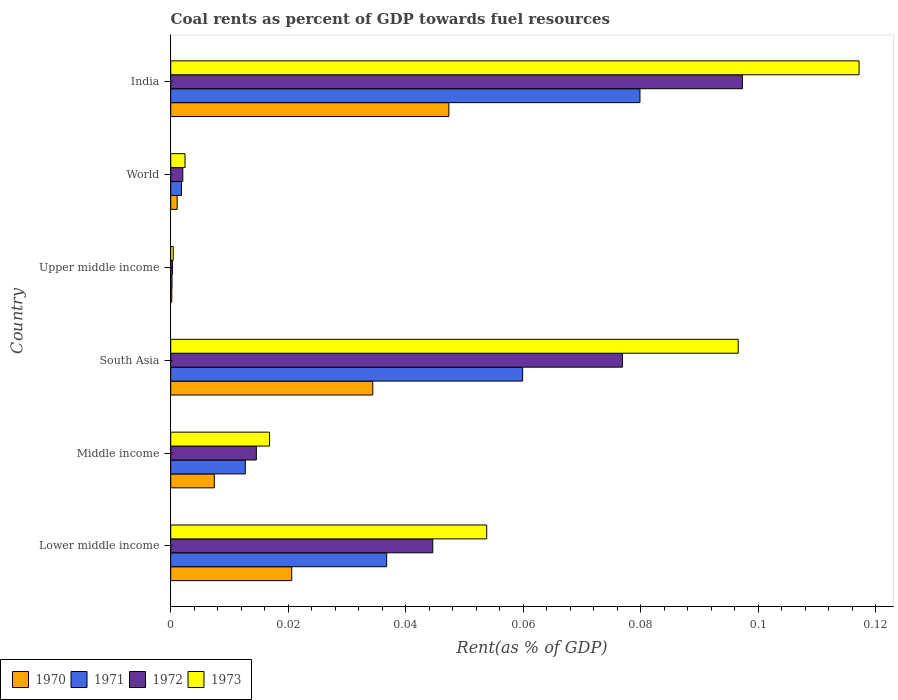How many groups of bars are there?
Your answer should be compact. 6. Are the number of bars on each tick of the Y-axis equal?
Provide a succinct answer. Yes. How many bars are there on the 5th tick from the top?
Offer a very short reply. 4. How many bars are there on the 6th tick from the bottom?
Give a very brief answer. 4. In how many cases, is the number of bars for a given country not equal to the number of legend labels?
Your answer should be very brief. 0. What is the coal rent in 1972 in India?
Your answer should be compact. 0.1. Across all countries, what is the maximum coal rent in 1971?
Your answer should be very brief. 0.08. Across all countries, what is the minimum coal rent in 1971?
Give a very brief answer. 0. In which country was the coal rent in 1973 minimum?
Provide a short and direct response. Upper middle income. What is the total coal rent in 1972 in the graph?
Your answer should be very brief. 0.24. What is the difference between the coal rent in 1970 in Middle income and that in Upper middle income?
Keep it short and to the point. 0.01. What is the difference between the coal rent in 1970 in Lower middle income and the coal rent in 1973 in Middle income?
Offer a very short reply. 0. What is the average coal rent in 1970 per country?
Ensure brevity in your answer.  0.02. What is the difference between the coal rent in 1971 and coal rent in 1970 in Lower middle income?
Provide a succinct answer. 0.02. What is the ratio of the coal rent in 1972 in India to that in Lower middle income?
Provide a short and direct response. 2.18. What is the difference between the highest and the second highest coal rent in 1972?
Make the answer very short. 0.02. What is the difference between the highest and the lowest coal rent in 1972?
Make the answer very short. 0.1. Are the values on the major ticks of X-axis written in scientific E-notation?
Offer a very short reply. No. Does the graph contain any zero values?
Offer a terse response. No. How are the legend labels stacked?
Your response must be concise. Horizontal. What is the title of the graph?
Ensure brevity in your answer.  Coal rents as percent of GDP towards fuel resources. Does "1979" appear as one of the legend labels in the graph?
Your answer should be very brief. No. What is the label or title of the X-axis?
Your answer should be very brief. Rent(as % of GDP). What is the label or title of the Y-axis?
Provide a succinct answer. Country. What is the Rent(as % of GDP) in 1970 in Lower middle income?
Make the answer very short. 0.02. What is the Rent(as % of GDP) in 1971 in Lower middle income?
Keep it short and to the point. 0.04. What is the Rent(as % of GDP) in 1972 in Lower middle income?
Make the answer very short. 0.04. What is the Rent(as % of GDP) in 1973 in Lower middle income?
Your response must be concise. 0.05. What is the Rent(as % of GDP) in 1970 in Middle income?
Provide a succinct answer. 0.01. What is the Rent(as % of GDP) of 1971 in Middle income?
Provide a succinct answer. 0.01. What is the Rent(as % of GDP) in 1972 in Middle income?
Offer a terse response. 0.01. What is the Rent(as % of GDP) in 1973 in Middle income?
Your answer should be very brief. 0.02. What is the Rent(as % of GDP) of 1970 in South Asia?
Offer a terse response. 0.03. What is the Rent(as % of GDP) of 1971 in South Asia?
Your answer should be very brief. 0.06. What is the Rent(as % of GDP) in 1972 in South Asia?
Provide a succinct answer. 0.08. What is the Rent(as % of GDP) of 1973 in South Asia?
Keep it short and to the point. 0.1. What is the Rent(as % of GDP) in 1970 in Upper middle income?
Keep it short and to the point. 0. What is the Rent(as % of GDP) of 1971 in Upper middle income?
Give a very brief answer. 0. What is the Rent(as % of GDP) in 1972 in Upper middle income?
Give a very brief answer. 0. What is the Rent(as % of GDP) of 1973 in Upper middle income?
Your response must be concise. 0. What is the Rent(as % of GDP) in 1970 in World?
Offer a terse response. 0. What is the Rent(as % of GDP) in 1971 in World?
Your answer should be compact. 0. What is the Rent(as % of GDP) of 1972 in World?
Keep it short and to the point. 0. What is the Rent(as % of GDP) of 1973 in World?
Make the answer very short. 0. What is the Rent(as % of GDP) in 1970 in India?
Ensure brevity in your answer.  0.05. What is the Rent(as % of GDP) in 1971 in India?
Your answer should be compact. 0.08. What is the Rent(as % of GDP) in 1972 in India?
Offer a very short reply. 0.1. What is the Rent(as % of GDP) in 1973 in India?
Give a very brief answer. 0.12. Across all countries, what is the maximum Rent(as % of GDP) in 1970?
Offer a very short reply. 0.05. Across all countries, what is the maximum Rent(as % of GDP) in 1971?
Give a very brief answer. 0.08. Across all countries, what is the maximum Rent(as % of GDP) in 1972?
Provide a short and direct response. 0.1. Across all countries, what is the maximum Rent(as % of GDP) in 1973?
Keep it short and to the point. 0.12. Across all countries, what is the minimum Rent(as % of GDP) in 1970?
Make the answer very short. 0. Across all countries, what is the minimum Rent(as % of GDP) in 1971?
Ensure brevity in your answer.  0. Across all countries, what is the minimum Rent(as % of GDP) of 1972?
Keep it short and to the point. 0. Across all countries, what is the minimum Rent(as % of GDP) of 1973?
Your answer should be very brief. 0. What is the total Rent(as % of GDP) of 1970 in the graph?
Make the answer very short. 0.11. What is the total Rent(as % of GDP) of 1971 in the graph?
Offer a very short reply. 0.19. What is the total Rent(as % of GDP) in 1972 in the graph?
Offer a terse response. 0.24. What is the total Rent(as % of GDP) of 1973 in the graph?
Offer a very short reply. 0.29. What is the difference between the Rent(as % of GDP) of 1970 in Lower middle income and that in Middle income?
Your answer should be compact. 0.01. What is the difference between the Rent(as % of GDP) of 1971 in Lower middle income and that in Middle income?
Keep it short and to the point. 0.02. What is the difference between the Rent(as % of GDP) in 1972 in Lower middle income and that in Middle income?
Ensure brevity in your answer.  0.03. What is the difference between the Rent(as % of GDP) in 1973 in Lower middle income and that in Middle income?
Your answer should be compact. 0.04. What is the difference between the Rent(as % of GDP) of 1970 in Lower middle income and that in South Asia?
Provide a short and direct response. -0.01. What is the difference between the Rent(as % of GDP) in 1971 in Lower middle income and that in South Asia?
Offer a very short reply. -0.02. What is the difference between the Rent(as % of GDP) of 1972 in Lower middle income and that in South Asia?
Your answer should be compact. -0.03. What is the difference between the Rent(as % of GDP) in 1973 in Lower middle income and that in South Asia?
Your answer should be very brief. -0.04. What is the difference between the Rent(as % of GDP) in 1970 in Lower middle income and that in Upper middle income?
Provide a short and direct response. 0.02. What is the difference between the Rent(as % of GDP) of 1971 in Lower middle income and that in Upper middle income?
Offer a terse response. 0.04. What is the difference between the Rent(as % of GDP) in 1972 in Lower middle income and that in Upper middle income?
Your response must be concise. 0.04. What is the difference between the Rent(as % of GDP) in 1973 in Lower middle income and that in Upper middle income?
Offer a very short reply. 0.05. What is the difference between the Rent(as % of GDP) in 1970 in Lower middle income and that in World?
Your answer should be very brief. 0.02. What is the difference between the Rent(as % of GDP) of 1971 in Lower middle income and that in World?
Offer a terse response. 0.03. What is the difference between the Rent(as % of GDP) of 1972 in Lower middle income and that in World?
Keep it short and to the point. 0.04. What is the difference between the Rent(as % of GDP) in 1973 in Lower middle income and that in World?
Ensure brevity in your answer.  0.05. What is the difference between the Rent(as % of GDP) of 1970 in Lower middle income and that in India?
Provide a succinct answer. -0.03. What is the difference between the Rent(as % of GDP) in 1971 in Lower middle income and that in India?
Keep it short and to the point. -0.04. What is the difference between the Rent(as % of GDP) in 1972 in Lower middle income and that in India?
Keep it short and to the point. -0.05. What is the difference between the Rent(as % of GDP) in 1973 in Lower middle income and that in India?
Offer a very short reply. -0.06. What is the difference between the Rent(as % of GDP) in 1970 in Middle income and that in South Asia?
Your answer should be very brief. -0.03. What is the difference between the Rent(as % of GDP) of 1971 in Middle income and that in South Asia?
Give a very brief answer. -0.05. What is the difference between the Rent(as % of GDP) in 1972 in Middle income and that in South Asia?
Your answer should be very brief. -0.06. What is the difference between the Rent(as % of GDP) of 1973 in Middle income and that in South Asia?
Give a very brief answer. -0.08. What is the difference between the Rent(as % of GDP) in 1970 in Middle income and that in Upper middle income?
Make the answer very short. 0.01. What is the difference between the Rent(as % of GDP) of 1971 in Middle income and that in Upper middle income?
Keep it short and to the point. 0.01. What is the difference between the Rent(as % of GDP) of 1972 in Middle income and that in Upper middle income?
Provide a succinct answer. 0.01. What is the difference between the Rent(as % of GDP) of 1973 in Middle income and that in Upper middle income?
Provide a succinct answer. 0.02. What is the difference between the Rent(as % of GDP) of 1970 in Middle income and that in World?
Your answer should be very brief. 0.01. What is the difference between the Rent(as % of GDP) of 1971 in Middle income and that in World?
Your answer should be very brief. 0.01. What is the difference between the Rent(as % of GDP) of 1972 in Middle income and that in World?
Make the answer very short. 0.01. What is the difference between the Rent(as % of GDP) in 1973 in Middle income and that in World?
Ensure brevity in your answer.  0.01. What is the difference between the Rent(as % of GDP) of 1970 in Middle income and that in India?
Your answer should be compact. -0.04. What is the difference between the Rent(as % of GDP) in 1971 in Middle income and that in India?
Offer a terse response. -0.07. What is the difference between the Rent(as % of GDP) in 1972 in Middle income and that in India?
Give a very brief answer. -0.08. What is the difference between the Rent(as % of GDP) in 1973 in Middle income and that in India?
Your answer should be very brief. -0.1. What is the difference between the Rent(as % of GDP) of 1970 in South Asia and that in Upper middle income?
Your answer should be compact. 0.03. What is the difference between the Rent(as % of GDP) of 1971 in South Asia and that in Upper middle income?
Your answer should be very brief. 0.06. What is the difference between the Rent(as % of GDP) in 1972 in South Asia and that in Upper middle income?
Offer a very short reply. 0.08. What is the difference between the Rent(as % of GDP) of 1973 in South Asia and that in Upper middle income?
Offer a very short reply. 0.1. What is the difference between the Rent(as % of GDP) in 1970 in South Asia and that in World?
Your response must be concise. 0.03. What is the difference between the Rent(as % of GDP) of 1971 in South Asia and that in World?
Your answer should be very brief. 0.06. What is the difference between the Rent(as % of GDP) in 1972 in South Asia and that in World?
Offer a terse response. 0.07. What is the difference between the Rent(as % of GDP) of 1973 in South Asia and that in World?
Offer a very short reply. 0.09. What is the difference between the Rent(as % of GDP) in 1970 in South Asia and that in India?
Your response must be concise. -0.01. What is the difference between the Rent(as % of GDP) in 1971 in South Asia and that in India?
Give a very brief answer. -0.02. What is the difference between the Rent(as % of GDP) in 1972 in South Asia and that in India?
Your response must be concise. -0.02. What is the difference between the Rent(as % of GDP) of 1973 in South Asia and that in India?
Provide a short and direct response. -0.02. What is the difference between the Rent(as % of GDP) in 1970 in Upper middle income and that in World?
Provide a short and direct response. -0. What is the difference between the Rent(as % of GDP) in 1971 in Upper middle income and that in World?
Provide a succinct answer. -0. What is the difference between the Rent(as % of GDP) in 1972 in Upper middle income and that in World?
Keep it short and to the point. -0. What is the difference between the Rent(as % of GDP) in 1973 in Upper middle income and that in World?
Your answer should be compact. -0. What is the difference between the Rent(as % of GDP) of 1970 in Upper middle income and that in India?
Your response must be concise. -0.05. What is the difference between the Rent(as % of GDP) of 1971 in Upper middle income and that in India?
Give a very brief answer. -0.08. What is the difference between the Rent(as % of GDP) in 1972 in Upper middle income and that in India?
Your answer should be compact. -0.1. What is the difference between the Rent(as % of GDP) in 1973 in Upper middle income and that in India?
Your answer should be very brief. -0.12. What is the difference between the Rent(as % of GDP) of 1970 in World and that in India?
Keep it short and to the point. -0.05. What is the difference between the Rent(as % of GDP) of 1971 in World and that in India?
Offer a terse response. -0.08. What is the difference between the Rent(as % of GDP) of 1972 in World and that in India?
Offer a very short reply. -0.1. What is the difference between the Rent(as % of GDP) in 1973 in World and that in India?
Offer a terse response. -0.11. What is the difference between the Rent(as % of GDP) of 1970 in Lower middle income and the Rent(as % of GDP) of 1971 in Middle income?
Your answer should be very brief. 0.01. What is the difference between the Rent(as % of GDP) in 1970 in Lower middle income and the Rent(as % of GDP) in 1972 in Middle income?
Your response must be concise. 0.01. What is the difference between the Rent(as % of GDP) in 1970 in Lower middle income and the Rent(as % of GDP) in 1973 in Middle income?
Your response must be concise. 0. What is the difference between the Rent(as % of GDP) of 1971 in Lower middle income and the Rent(as % of GDP) of 1972 in Middle income?
Make the answer very short. 0.02. What is the difference between the Rent(as % of GDP) in 1971 in Lower middle income and the Rent(as % of GDP) in 1973 in Middle income?
Make the answer very short. 0.02. What is the difference between the Rent(as % of GDP) of 1972 in Lower middle income and the Rent(as % of GDP) of 1973 in Middle income?
Make the answer very short. 0.03. What is the difference between the Rent(as % of GDP) in 1970 in Lower middle income and the Rent(as % of GDP) in 1971 in South Asia?
Offer a very short reply. -0.04. What is the difference between the Rent(as % of GDP) in 1970 in Lower middle income and the Rent(as % of GDP) in 1972 in South Asia?
Offer a very short reply. -0.06. What is the difference between the Rent(as % of GDP) of 1970 in Lower middle income and the Rent(as % of GDP) of 1973 in South Asia?
Your answer should be very brief. -0.08. What is the difference between the Rent(as % of GDP) of 1971 in Lower middle income and the Rent(as % of GDP) of 1972 in South Asia?
Your answer should be compact. -0.04. What is the difference between the Rent(as % of GDP) in 1971 in Lower middle income and the Rent(as % of GDP) in 1973 in South Asia?
Give a very brief answer. -0.06. What is the difference between the Rent(as % of GDP) in 1972 in Lower middle income and the Rent(as % of GDP) in 1973 in South Asia?
Make the answer very short. -0.05. What is the difference between the Rent(as % of GDP) of 1970 in Lower middle income and the Rent(as % of GDP) of 1971 in Upper middle income?
Offer a very short reply. 0.02. What is the difference between the Rent(as % of GDP) in 1970 in Lower middle income and the Rent(as % of GDP) in 1972 in Upper middle income?
Your answer should be very brief. 0.02. What is the difference between the Rent(as % of GDP) of 1970 in Lower middle income and the Rent(as % of GDP) of 1973 in Upper middle income?
Give a very brief answer. 0.02. What is the difference between the Rent(as % of GDP) in 1971 in Lower middle income and the Rent(as % of GDP) in 1972 in Upper middle income?
Provide a short and direct response. 0.04. What is the difference between the Rent(as % of GDP) of 1971 in Lower middle income and the Rent(as % of GDP) of 1973 in Upper middle income?
Give a very brief answer. 0.04. What is the difference between the Rent(as % of GDP) in 1972 in Lower middle income and the Rent(as % of GDP) in 1973 in Upper middle income?
Provide a short and direct response. 0.04. What is the difference between the Rent(as % of GDP) in 1970 in Lower middle income and the Rent(as % of GDP) in 1971 in World?
Keep it short and to the point. 0.02. What is the difference between the Rent(as % of GDP) in 1970 in Lower middle income and the Rent(as % of GDP) in 1972 in World?
Offer a terse response. 0.02. What is the difference between the Rent(as % of GDP) in 1970 in Lower middle income and the Rent(as % of GDP) in 1973 in World?
Your response must be concise. 0.02. What is the difference between the Rent(as % of GDP) of 1971 in Lower middle income and the Rent(as % of GDP) of 1972 in World?
Keep it short and to the point. 0.03. What is the difference between the Rent(as % of GDP) in 1971 in Lower middle income and the Rent(as % of GDP) in 1973 in World?
Provide a short and direct response. 0.03. What is the difference between the Rent(as % of GDP) in 1972 in Lower middle income and the Rent(as % of GDP) in 1973 in World?
Make the answer very short. 0.04. What is the difference between the Rent(as % of GDP) of 1970 in Lower middle income and the Rent(as % of GDP) of 1971 in India?
Provide a succinct answer. -0.06. What is the difference between the Rent(as % of GDP) of 1970 in Lower middle income and the Rent(as % of GDP) of 1972 in India?
Offer a terse response. -0.08. What is the difference between the Rent(as % of GDP) of 1970 in Lower middle income and the Rent(as % of GDP) of 1973 in India?
Ensure brevity in your answer.  -0.1. What is the difference between the Rent(as % of GDP) in 1971 in Lower middle income and the Rent(as % of GDP) in 1972 in India?
Provide a short and direct response. -0.06. What is the difference between the Rent(as % of GDP) in 1971 in Lower middle income and the Rent(as % of GDP) in 1973 in India?
Offer a terse response. -0.08. What is the difference between the Rent(as % of GDP) of 1972 in Lower middle income and the Rent(as % of GDP) of 1973 in India?
Offer a very short reply. -0.07. What is the difference between the Rent(as % of GDP) of 1970 in Middle income and the Rent(as % of GDP) of 1971 in South Asia?
Give a very brief answer. -0.05. What is the difference between the Rent(as % of GDP) of 1970 in Middle income and the Rent(as % of GDP) of 1972 in South Asia?
Your answer should be very brief. -0.07. What is the difference between the Rent(as % of GDP) of 1970 in Middle income and the Rent(as % of GDP) of 1973 in South Asia?
Provide a short and direct response. -0.09. What is the difference between the Rent(as % of GDP) in 1971 in Middle income and the Rent(as % of GDP) in 1972 in South Asia?
Offer a very short reply. -0.06. What is the difference between the Rent(as % of GDP) of 1971 in Middle income and the Rent(as % of GDP) of 1973 in South Asia?
Your response must be concise. -0.08. What is the difference between the Rent(as % of GDP) of 1972 in Middle income and the Rent(as % of GDP) of 1973 in South Asia?
Give a very brief answer. -0.08. What is the difference between the Rent(as % of GDP) of 1970 in Middle income and the Rent(as % of GDP) of 1971 in Upper middle income?
Offer a very short reply. 0.01. What is the difference between the Rent(as % of GDP) of 1970 in Middle income and the Rent(as % of GDP) of 1972 in Upper middle income?
Offer a terse response. 0.01. What is the difference between the Rent(as % of GDP) of 1970 in Middle income and the Rent(as % of GDP) of 1973 in Upper middle income?
Ensure brevity in your answer.  0.01. What is the difference between the Rent(as % of GDP) of 1971 in Middle income and the Rent(as % of GDP) of 1972 in Upper middle income?
Your response must be concise. 0.01. What is the difference between the Rent(as % of GDP) of 1971 in Middle income and the Rent(as % of GDP) of 1973 in Upper middle income?
Offer a terse response. 0.01. What is the difference between the Rent(as % of GDP) of 1972 in Middle income and the Rent(as % of GDP) of 1973 in Upper middle income?
Your answer should be very brief. 0.01. What is the difference between the Rent(as % of GDP) of 1970 in Middle income and the Rent(as % of GDP) of 1971 in World?
Provide a short and direct response. 0.01. What is the difference between the Rent(as % of GDP) of 1970 in Middle income and the Rent(as % of GDP) of 1972 in World?
Ensure brevity in your answer.  0.01. What is the difference between the Rent(as % of GDP) in 1970 in Middle income and the Rent(as % of GDP) in 1973 in World?
Provide a short and direct response. 0.01. What is the difference between the Rent(as % of GDP) of 1971 in Middle income and the Rent(as % of GDP) of 1972 in World?
Ensure brevity in your answer.  0.01. What is the difference between the Rent(as % of GDP) of 1971 in Middle income and the Rent(as % of GDP) of 1973 in World?
Your answer should be very brief. 0.01. What is the difference between the Rent(as % of GDP) of 1972 in Middle income and the Rent(as % of GDP) of 1973 in World?
Keep it short and to the point. 0.01. What is the difference between the Rent(as % of GDP) of 1970 in Middle income and the Rent(as % of GDP) of 1971 in India?
Ensure brevity in your answer.  -0.07. What is the difference between the Rent(as % of GDP) in 1970 in Middle income and the Rent(as % of GDP) in 1972 in India?
Your answer should be compact. -0.09. What is the difference between the Rent(as % of GDP) in 1970 in Middle income and the Rent(as % of GDP) in 1973 in India?
Offer a terse response. -0.11. What is the difference between the Rent(as % of GDP) in 1971 in Middle income and the Rent(as % of GDP) in 1972 in India?
Keep it short and to the point. -0.08. What is the difference between the Rent(as % of GDP) in 1971 in Middle income and the Rent(as % of GDP) in 1973 in India?
Your answer should be compact. -0.1. What is the difference between the Rent(as % of GDP) of 1972 in Middle income and the Rent(as % of GDP) of 1973 in India?
Your response must be concise. -0.1. What is the difference between the Rent(as % of GDP) of 1970 in South Asia and the Rent(as % of GDP) of 1971 in Upper middle income?
Your answer should be compact. 0.03. What is the difference between the Rent(as % of GDP) of 1970 in South Asia and the Rent(as % of GDP) of 1972 in Upper middle income?
Provide a succinct answer. 0.03. What is the difference between the Rent(as % of GDP) of 1970 in South Asia and the Rent(as % of GDP) of 1973 in Upper middle income?
Provide a short and direct response. 0.03. What is the difference between the Rent(as % of GDP) of 1971 in South Asia and the Rent(as % of GDP) of 1972 in Upper middle income?
Make the answer very short. 0.06. What is the difference between the Rent(as % of GDP) in 1971 in South Asia and the Rent(as % of GDP) in 1973 in Upper middle income?
Offer a terse response. 0.06. What is the difference between the Rent(as % of GDP) of 1972 in South Asia and the Rent(as % of GDP) of 1973 in Upper middle income?
Keep it short and to the point. 0.08. What is the difference between the Rent(as % of GDP) in 1970 in South Asia and the Rent(as % of GDP) in 1971 in World?
Provide a succinct answer. 0.03. What is the difference between the Rent(as % of GDP) of 1970 in South Asia and the Rent(as % of GDP) of 1972 in World?
Your answer should be very brief. 0.03. What is the difference between the Rent(as % of GDP) in 1970 in South Asia and the Rent(as % of GDP) in 1973 in World?
Give a very brief answer. 0.03. What is the difference between the Rent(as % of GDP) in 1971 in South Asia and the Rent(as % of GDP) in 1972 in World?
Provide a succinct answer. 0.06. What is the difference between the Rent(as % of GDP) in 1971 in South Asia and the Rent(as % of GDP) in 1973 in World?
Your answer should be very brief. 0.06. What is the difference between the Rent(as % of GDP) of 1972 in South Asia and the Rent(as % of GDP) of 1973 in World?
Provide a short and direct response. 0.07. What is the difference between the Rent(as % of GDP) of 1970 in South Asia and the Rent(as % of GDP) of 1971 in India?
Your answer should be compact. -0.05. What is the difference between the Rent(as % of GDP) in 1970 in South Asia and the Rent(as % of GDP) in 1972 in India?
Give a very brief answer. -0.06. What is the difference between the Rent(as % of GDP) in 1970 in South Asia and the Rent(as % of GDP) in 1973 in India?
Provide a succinct answer. -0.08. What is the difference between the Rent(as % of GDP) of 1971 in South Asia and the Rent(as % of GDP) of 1972 in India?
Keep it short and to the point. -0.04. What is the difference between the Rent(as % of GDP) in 1971 in South Asia and the Rent(as % of GDP) in 1973 in India?
Provide a short and direct response. -0.06. What is the difference between the Rent(as % of GDP) in 1972 in South Asia and the Rent(as % of GDP) in 1973 in India?
Offer a terse response. -0.04. What is the difference between the Rent(as % of GDP) of 1970 in Upper middle income and the Rent(as % of GDP) of 1971 in World?
Keep it short and to the point. -0. What is the difference between the Rent(as % of GDP) in 1970 in Upper middle income and the Rent(as % of GDP) in 1972 in World?
Offer a very short reply. -0. What is the difference between the Rent(as % of GDP) of 1970 in Upper middle income and the Rent(as % of GDP) of 1973 in World?
Your response must be concise. -0. What is the difference between the Rent(as % of GDP) in 1971 in Upper middle income and the Rent(as % of GDP) in 1972 in World?
Keep it short and to the point. -0. What is the difference between the Rent(as % of GDP) of 1971 in Upper middle income and the Rent(as % of GDP) of 1973 in World?
Your answer should be compact. -0. What is the difference between the Rent(as % of GDP) of 1972 in Upper middle income and the Rent(as % of GDP) of 1973 in World?
Make the answer very short. -0. What is the difference between the Rent(as % of GDP) in 1970 in Upper middle income and the Rent(as % of GDP) in 1971 in India?
Your response must be concise. -0.08. What is the difference between the Rent(as % of GDP) of 1970 in Upper middle income and the Rent(as % of GDP) of 1972 in India?
Ensure brevity in your answer.  -0.1. What is the difference between the Rent(as % of GDP) in 1970 in Upper middle income and the Rent(as % of GDP) in 1973 in India?
Your answer should be compact. -0.12. What is the difference between the Rent(as % of GDP) in 1971 in Upper middle income and the Rent(as % of GDP) in 1972 in India?
Your answer should be compact. -0.1. What is the difference between the Rent(as % of GDP) of 1971 in Upper middle income and the Rent(as % of GDP) of 1973 in India?
Ensure brevity in your answer.  -0.12. What is the difference between the Rent(as % of GDP) of 1972 in Upper middle income and the Rent(as % of GDP) of 1973 in India?
Offer a terse response. -0.12. What is the difference between the Rent(as % of GDP) in 1970 in World and the Rent(as % of GDP) in 1971 in India?
Offer a terse response. -0.08. What is the difference between the Rent(as % of GDP) in 1970 in World and the Rent(as % of GDP) in 1972 in India?
Provide a succinct answer. -0.1. What is the difference between the Rent(as % of GDP) in 1970 in World and the Rent(as % of GDP) in 1973 in India?
Ensure brevity in your answer.  -0.12. What is the difference between the Rent(as % of GDP) in 1971 in World and the Rent(as % of GDP) in 1972 in India?
Your response must be concise. -0.1. What is the difference between the Rent(as % of GDP) of 1971 in World and the Rent(as % of GDP) of 1973 in India?
Provide a short and direct response. -0.12. What is the difference between the Rent(as % of GDP) in 1972 in World and the Rent(as % of GDP) in 1973 in India?
Keep it short and to the point. -0.12. What is the average Rent(as % of GDP) in 1970 per country?
Provide a short and direct response. 0.02. What is the average Rent(as % of GDP) in 1971 per country?
Give a very brief answer. 0.03. What is the average Rent(as % of GDP) of 1972 per country?
Your response must be concise. 0.04. What is the average Rent(as % of GDP) of 1973 per country?
Keep it short and to the point. 0.05. What is the difference between the Rent(as % of GDP) of 1970 and Rent(as % of GDP) of 1971 in Lower middle income?
Give a very brief answer. -0.02. What is the difference between the Rent(as % of GDP) in 1970 and Rent(as % of GDP) in 1972 in Lower middle income?
Your answer should be very brief. -0.02. What is the difference between the Rent(as % of GDP) in 1970 and Rent(as % of GDP) in 1973 in Lower middle income?
Your answer should be very brief. -0.03. What is the difference between the Rent(as % of GDP) in 1971 and Rent(as % of GDP) in 1972 in Lower middle income?
Give a very brief answer. -0.01. What is the difference between the Rent(as % of GDP) of 1971 and Rent(as % of GDP) of 1973 in Lower middle income?
Give a very brief answer. -0.02. What is the difference between the Rent(as % of GDP) in 1972 and Rent(as % of GDP) in 1973 in Lower middle income?
Give a very brief answer. -0.01. What is the difference between the Rent(as % of GDP) in 1970 and Rent(as % of GDP) in 1971 in Middle income?
Offer a very short reply. -0.01. What is the difference between the Rent(as % of GDP) in 1970 and Rent(as % of GDP) in 1972 in Middle income?
Make the answer very short. -0.01. What is the difference between the Rent(as % of GDP) of 1970 and Rent(as % of GDP) of 1973 in Middle income?
Give a very brief answer. -0.01. What is the difference between the Rent(as % of GDP) of 1971 and Rent(as % of GDP) of 1972 in Middle income?
Give a very brief answer. -0. What is the difference between the Rent(as % of GDP) of 1971 and Rent(as % of GDP) of 1973 in Middle income?
Your response must be concise. -0. What is the difference between the Rent(as % of GDP) of 1972 and Rent(as % of GDP) of 1973 in Middle income?
Keep it short and to the point. -0. What is the difference between the Rent(as % of GDP) of 1970 and Rent(as % of GDP) of 1971 in South Asia?
Make the answer very short. -0.03. What is the difference between the Rent(as % of GDP) of 1970 and Rent(as % of GDP) of 1972 in South Asia?
Provide a succinct answer. -0.04. What is the difference between the Rent(as % of GDP) of 1970 and Rent(as % of GDP) of 1973 in South Asia?
Offer a terse response. -0.06. What is the difference between the Rent(as % of GDP) in 1971 and Rent(as % of GDP) in 1972 in South Asia?
Provide a succinct answer. -0.02. What is the difference between the Rent(as % of GDP) in 1971 and Rent(as % of GDP) in 1973 in South Asia?
Your response must be concise. -0.04. What is the difference between the Rent(as % of GDP) of 1972 and Rent(as % of GDP) of 1973 in South Asia?
Offer a terse response. -0.02. What is the difference between the Rent(as % of GDP) of 1970 and Rent(as % of GDP) of 1972 in Upper middle income?
Offer a very short reply. -0. What is the difference between the Rent(as % of GDP) in 1970 and Rent(as % of GDP) in 1973 in Upper middle income?
Ensure brevity in your answer.  -0. What is the difference between the Rent(as % of GDP) of 1971 and Rent(as % of GDP) of 1972 in Upper middle income?
Provide a succinct answer. -0. What is the difference between the Rent(as % of GDP) of 1971 and Rent(as % of GDP) of 1973 in Upper middle income?
Your answer should be very brief. -0. What is the difference between the Rent(as % of GDP) of 1972 and Rent(as % of GDP) of 1973 in Upper middle income?
Keep it short and to the point. -0. What is the difference between the Rent(as % of GDP) of 1970 and Rent(as % of GDP) of 1971 in World?
Offer a terse response. -0. What is the difference between the Rent(as % of GDP) of 1970 and Rent(as % of GDP) of 1972 in World?
Your response must be concise. -0. What is the difference between the Rent(as % of GDP) of 1970 and Rent(as % of GDP) of 1973 in World?
Provide a succinct answer. -0. What is the difference between the Rent(as % of GDP) in 1971 and Rent(as % of GDP) in 1972 in World?
Give a very brief answer. -0. What is the difference between the Rent(as % of GDP) of 1971 and Rent(as % of GDP) of 1973 in World?
Offer a very short reply. -0. What is the difference between the Rent(as % of GDP) in 1972 and Rent(as % of GDP) in 1973 in World?
Provide a short and direct response. -0. What is the difference between the Rent(as % of GDP) in 1970 and Rent(as % of GDP) in 1971 in India?
Ensure brevity in your answer.  -0.03. What is the difference between the Rent(as % of GDP) in 1970 and Rent(as % of GDP) in 1973 in India?
Your response must be concise. -0.07. What is the difference between the Rent(as % of GDP) of 1971 and Rent(as % of GDP) of 1972 in India?
Offer a very short reply. -0.02. What is the difference between the Rent(as % of GDP) in 1971 and Rent(as % of GDP) in 1973 in India?
Your response must be concise. -0.04. What is the difference between the Rent(as % of GDP) of 1972 and Rent(as % of GDP) of 1973 in India?
Provide a short and direct response. -0.02. What is the ratio of the Rent(as % of GDP) of 1970 in Lower middle income to that in Middle income?
Your response must be concise. 2.78. What is the ratio of the Rent(as % of GDP) in 1971 in Lower middle income to that in Middle income?
Your answer should be compact. 2.9. What is the ratio of the Rent(as % of GDP) of 1972 in Lower middle income to that in Middle income?
Offer a terse response. 3.06. What is the ratio of the Rent(as % of GDP) of 1973 in Lower middle income to that in Middle income?
Your answer should be compact. 3.2. What is the ratio of the Rent(as % of GDP) of 1970 in Lower middle income to that in South Asia?
Your response must be concise. 0.6. What is the ratio of the Rent(as % of GDP) in 1971 in Lower middle income to that in South Asia?
Your answer should be compact. 0.61. What is the ratio of the Rent(as % of GDP) of 1972 in Lower middle income to that in South Asia?
Make the answer very short. 0.58. What is the ratio of the Rent(as % of GDP) of 1973 in Lower middle income to that in South Asia?
Offer a terse response. 0.56. What is the ratio of the Rent(as % of GDP) of 1970 in Lower middle income to that in Upper middle income?
Your answer should be very brief. 112.03. What is the ratio of the Rent(as % of GDP) in 1971 in Lower middle income to that in Upper middle income?
Make the answer very short. 167.98. What is the ratio of the Rent(as % of GDP) in 1972 in Lower middle income to that in Upper middle income?
Make the answer very short. 156.82. What is the ratio of the Rent(as % of GDP) of 1973 in Lower middle income to that in Upper middle income?
Your answer should be very brief. 124.82. What is the ratio of the Rent(as % of GDP) of 1970 in Lower middle income to that in World?
Your answer should be very brief. 18.71. What is the ratio of the Rent(as % of GDP) of 1971 in Lower middle income to that in World?
Ensure brevity in your answer.  20.06. What is the ratio of the Rent(as % of GDP) in 1972 in Lower middle income to that in World?
Ensure brevity in your answer.  21.7. What is the ratio of the Rent(as % of GDP) in 1973 in Lower middle income to that in World?
Ensure brevity in your answer.  22.07. What is the ratio of the Rent(as % of GDP) of 1970 in Lower middle income to that in India?
Your response must be concise. 0.44. What is the ratio of the Rent(as % of GDP) of 1971 in Lower middle income to that in India?
Offer a terse response. 0.46. What is the ratio of the Rent(as % of GDP) of 1972 in Lower middle income to that in India?
Provide a succinct answer. 0.46. What is the ratio of the Rent(as % of GDP) of 1973 in Lower middle income to that in India?
Your answer should be compact. 0.46. What is the ratio of the Rent(as % of GDP) in 1970 in Middle income to that in South Asia?
Provide a short and direct response. 0.22. What is the ratio of the Rent(as % of GDP) in 1971 in Middle income to that in South Asia?
Give a very brief answer. 0.21. What is the ratio of the Rent(as % of GDP) of 1972 in Middle income to that in South Asia?
Keep it short and to the point. 0.19. What is the ratio of the Rent(as % of GDP) of 1973 in Middle income to that in South Asia?
Your answer should be very brief. 0.17. What is the ratio of the Rent(as % of GDP) of 1970 in Middle income to that in Upper middle income?
Offer a terse response. 40.36. What is the ratio of the Rent(as % of GDP) in 1971 in Middle income to that in Upper middle income?
Offer a terse response. 58.01. What is the ratio of the Rent(as % of GDP) in 1972 in Middle income to that in Upper middle income?
Ensure brevity in your answer.  51.25. What is the ratio of the Rent(as % of GDP) in 1973 in Middle income to that in Upper middle income?
Your answer should be compact. 39.04. What is the ratio of the Rent(as % of GDP) of 1970 in Middle income to that in World?
Offer a terse response. 6.74. What is the ratio of the Rent(as % of GDP) of 1971 in Middle income to that in World?
Make the answer very short. 6.93. What is the ratio of the Rent(as % of GDP) of 1972 in Middle income to that in World?
Keep it short and to the point. 7.09. What is the ratio of the Rent(as % of GDP) of 1973 in Middle income to that in World?
Your answer should be very brief. 6.91. What is the ratio of the Rent(as % of GDP) in 1970 in Middle income to that in India?
Ensure brevity in your answer.  0.16. What is the ratio of the Rent(as % of GDP) of 1971 in Middle income to that in India?
Your response must be concise. 0.16. What is the ratio of the Rent(as % of GDP) in 1972 in Middle income to that in India?
Your answer should be compact. 0.15. What is the ratio of the Rent(as % of GDP) in 1973 in Middle income to that in India?
Provide a succinct answer. 0.14. What is the ratio of the Rent(as % of GDP) of 1970 in South Asia to that in Upper middle income?
Offer a terse response. 187.05. What is the ratio of the Rent(as % of GDP) in 1971 in South Asia to that in Upper middle income?
Your answer should be very brief. 273.74. What is the ratio of the Rent(as % of GDP) in 1972 in South Asia to that in Upper middle income?
Your answer should be compact. 270.32. What is the ratio of the Rent(as % of GDP) in 1973 in South Asia to that in Upper middle income?
Offer a terse response. 224.18. What is the ratio of the Rent(as % of GDP) in 1970 in South Asia to that in World?
Make the answer very short. 31.24. What is the ratio of the Rent(as % of GDP) of 1971 in South Asia to that in World?
Ensure brevity in your answer.  32.69. What is the ratio of the Rent(as % of GDP) of 1972 in South Asia to that in World?
Offer a terse response. 37.41. What is the ratio of the Rent(as % of GDP) in 1973 in South Asia to that in World?
Your answer should be compact. 39.65. What is the ratio of the Rent(as % of GDP) of 1970 in South Asia to that in India?
Ensure brevity in your answer.  0.73. What is the ratio of the Rent(as % of GDP) in 1971 in South Asia to that in India?
Provide a succinct answer. 0.75. What is the ratio of the Rent(as % of GDP) in 1972 in South Asia to that in India?
Offer a terse response. 0.79. What is the ratio of the Rent(as % of GDP) of 1973 in South Asia to that in India?
Provide a short and direct response. 0.82. What is the ratio of the Rent(as % of GDP) of 1970 in Upper middle income to that in World?
Offer a terse response. 0.17. What is the ratio of the Rent(as % of GDP) in 1971 in Upper middle income to that in World?
Provide a short and direct response. 0.12. What is the ratio of the Rent(as % of GDP) in 1972 in Upper middle income to that in World?
Keep it short and to the point. 0.14. What is the ratio of the Rent(as % of GDP) in 1973 in Upper middle income to that in World?
Your answer should be compact. 0.18. What is the ratio of the Rent(as % of GDP) of 1970 in Upper middle income to that in India?
Make the answer very short. 0. What is the ratio of the Rent(as % of GDP) in 1971 in Upper middle income to that in India?
Your response must be concise. 0. What is the ratio of the Rent(as % of GDP) in 1972 in Upper middle income to that in India?
Offer a terse response. 0. What is the ratio of the Rent(as % of GDP) in 1973 in Upper middle income to that in India?
Give a very brief answer. 0. What is the ratio of the Rent(as % of GDP) of 1970 in World to that in India?
Your answer should be compact. 0.02. What is the ratio of the Rent(as % of GDP) in 1971 in World to that in India?
Provide a succinct answer. 0.02. What is the ratio of the Rent(as % of GDP) of 1972 in World to that in India?
Provide a short and direct response. 0.02. What is the ratio of the Rent(as % of GDP) of 1973 in World to that in India?
Ensure brevity in your answer.  0.02. What is the difference between the highest and the second highest Rent(as % of GDP) in 1970?
Provide a short and direct response. 0.01. What is the difference between the highest and the second highest Rent(as % of GDP) in 1971?
Provide a short and direct response. 0.02. What is the difference between the highest and the second highest Rent(as % of GDP) in 1972?
Your answer should be compact. 0.02. What is the difference between the highest and the second highest Rent(as % of GDP) in 1973?
Ensure brevity in your answer.  0.02. What is the difference between the highest and the lowest Rent(as % of GDP) in 1970?
Your answer should be compact. 0.05. What is the difference between the highest and the lowest Rent(as % of GDP) in 1971?
Keep it short and to the point. 0.08. What is the difference between the highest and the lowest Rent(as % of GDP) of 1972?
Give a very brief answer. 0.1. What is the difference between the highest and the lowest Rent(as % of GDP) of 1973?
Ensure brevity in your answer.  0.12. 